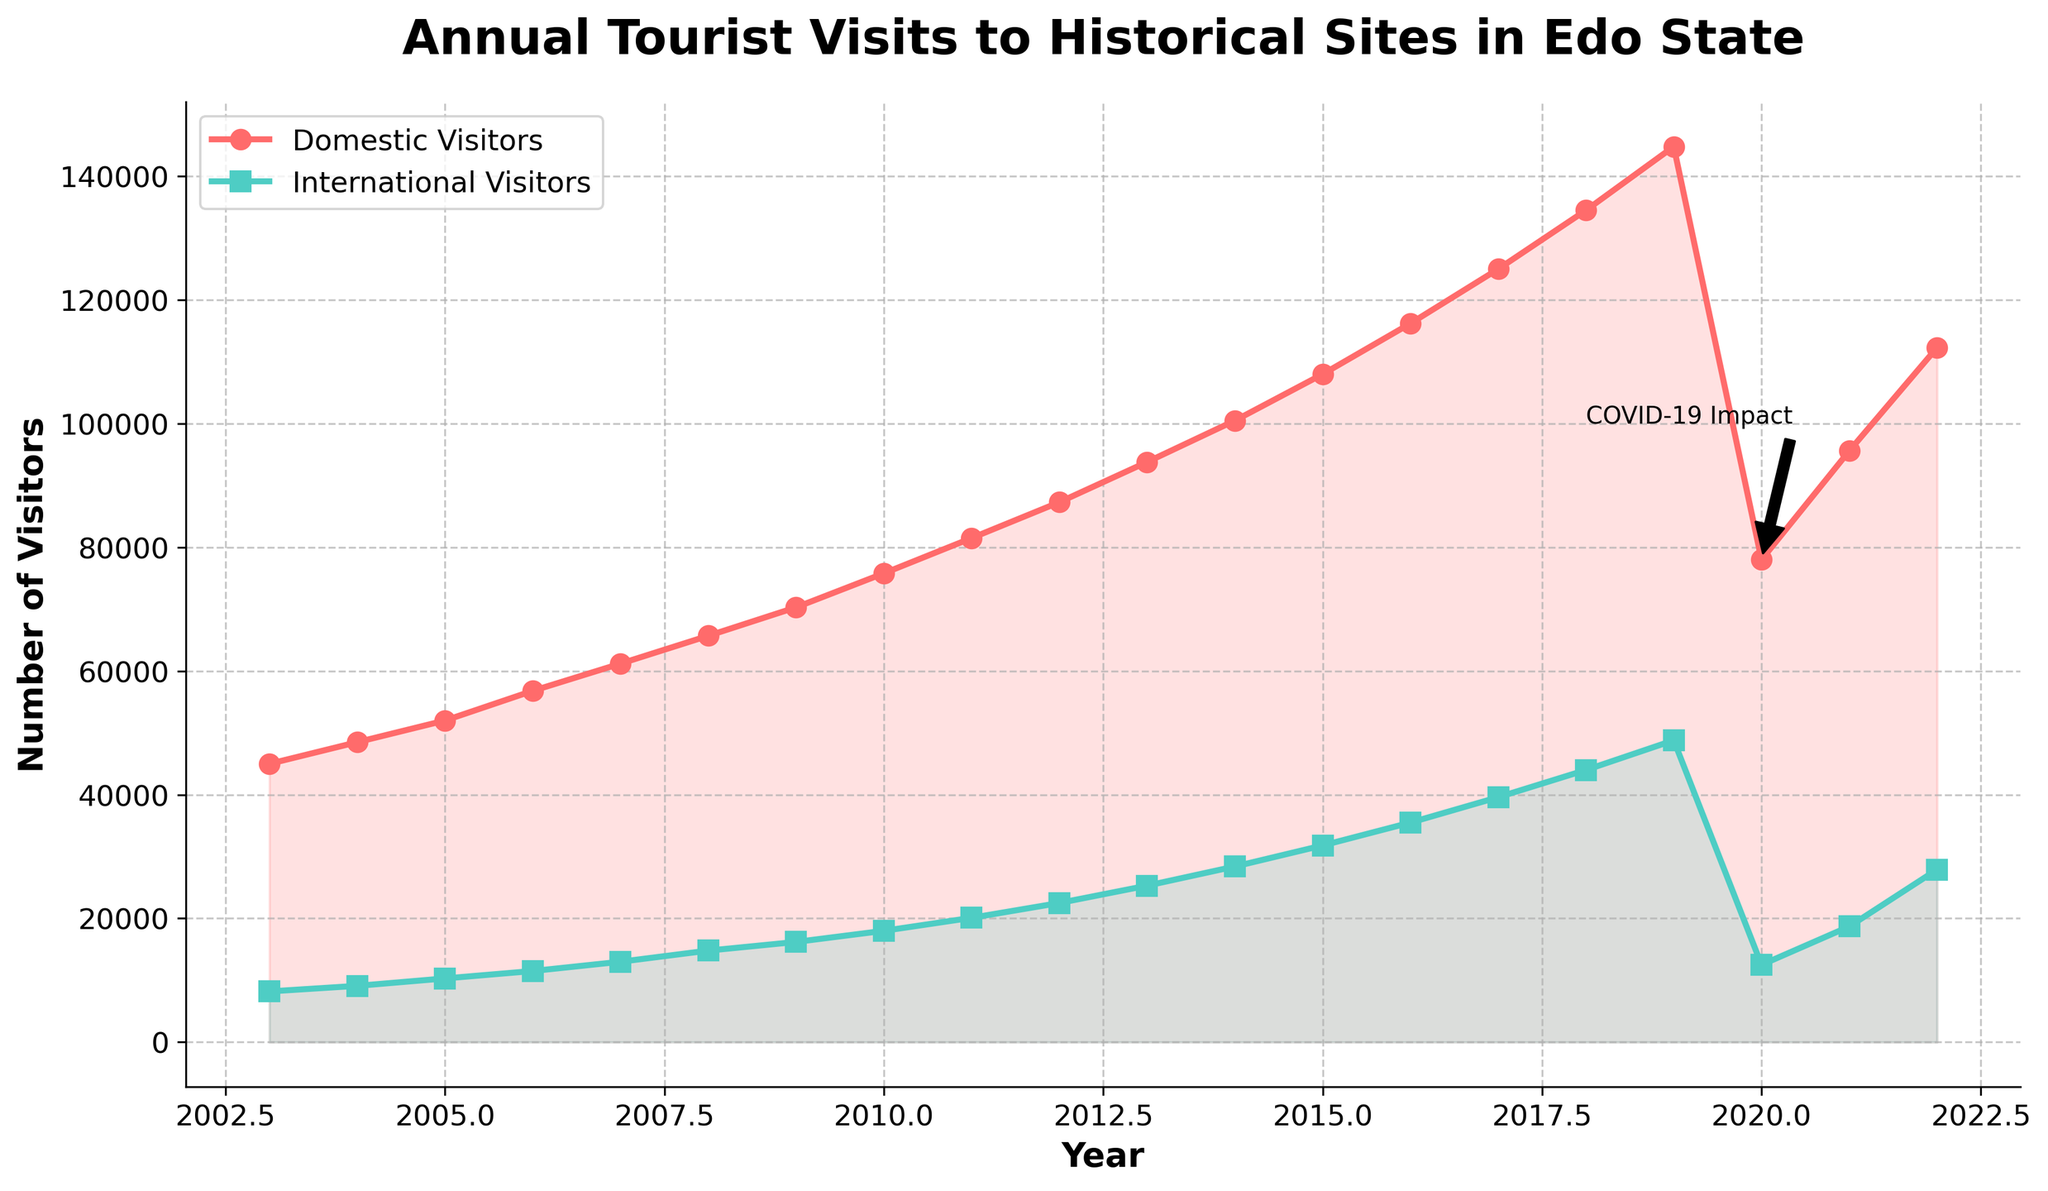What trend do we observe in the number of domestic and international visitors from 2003 to 2019? From 2003 to 2019, both domestic and international visitor numbers exhibit an upward trend, steadily increasing each year.
Answer: Increasing trend In which year did the number of domestic visitors peak, and what was the figure? The number of domestic visitors peaked in 2019, reaching a high of 144,800 visitors.
Answer: 2019, 144,800 visitors How did the number of international visitors in 2013 compare to 2015? In 2013, the number of international visitors was 25,300, while in 2015 it was 31,800, showing an increase by 6,500 visitors.
Answer: 2015 had 6,500 more visitors How did the COVID-19 pandemic affect tourism in 2020 compared to 2019? The number of domestic visitors dropped from 144,800 in 2019 to 78,000 in 2020, and international visitors decreased from 48,800 in 2019 to 12,500 in 2020, showing a significant decline due to COVID-19.
Answer: Significant decline What is the difference between the number of domestic and international visitors in 2022? In 2022, there were 112,300 domestic visitors and 27,900 international visitors. The difference is 112,300 - 27,900 = 84,400 visitors.
Answer: 84,400 visitors What can we infer about the recovery of tourist numbers from 2020 to 2022? From 2020 to 2022, the number of domestic visitors increased from 78,000 to 112,300 and international visitors from 12,500 to 27,900, indicating a recovery in tourist numbers post-COVID-19.
Answer: Recovery seen In which year did international visitors first exceed 20,000, and what was the number of domestic visitors that year? International visitors first exceeded 20,000 in 2011 with 20,100 visitors; that year, the number of domestic visitors was 81,500.
Answer: 2011, 81,500 visitors On the plot, which color represents domestic visitors and which represents international visitors? The plot shows domestic visitors in red and international visitors in green.
Answer: Red for domestic, green for international What can we conclude about the overall trend of international tourists visiting from 2003 to 2022? The number of international tourists displayed a general upward trend from 2003 to 2019, experienced a sharp drop in 2020, and then started to recover in subsequent years.
Answer: Upward trend with recovery post-2020 